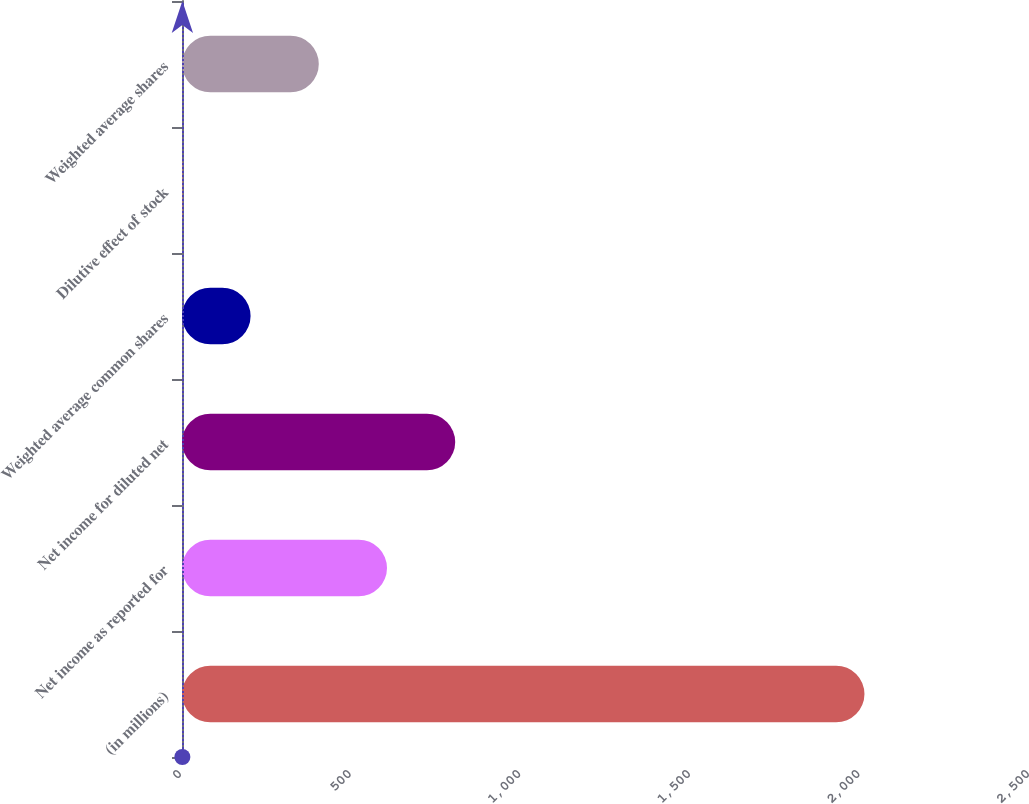Convert chart. <chart><loc_0><loc_0><loc_500><loc_500><bar_chart><fcel>(in millions)<fcel>Net income as reported for<fcel>Net income for diluted net<fcel>Weighted average common shares<fcel>Dilutive effect of stock<fcel>Weighted average shares<nl><fcel>2012<fcel>604.37<fcel>805.46<fcel>202.19<fcel>1.1<fcel>403.28<nl></chart> 